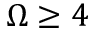Convert formula to latex. <formula><loc_0><loc_0><loc_500><loc_500>\Omega \geq 4</formula> 